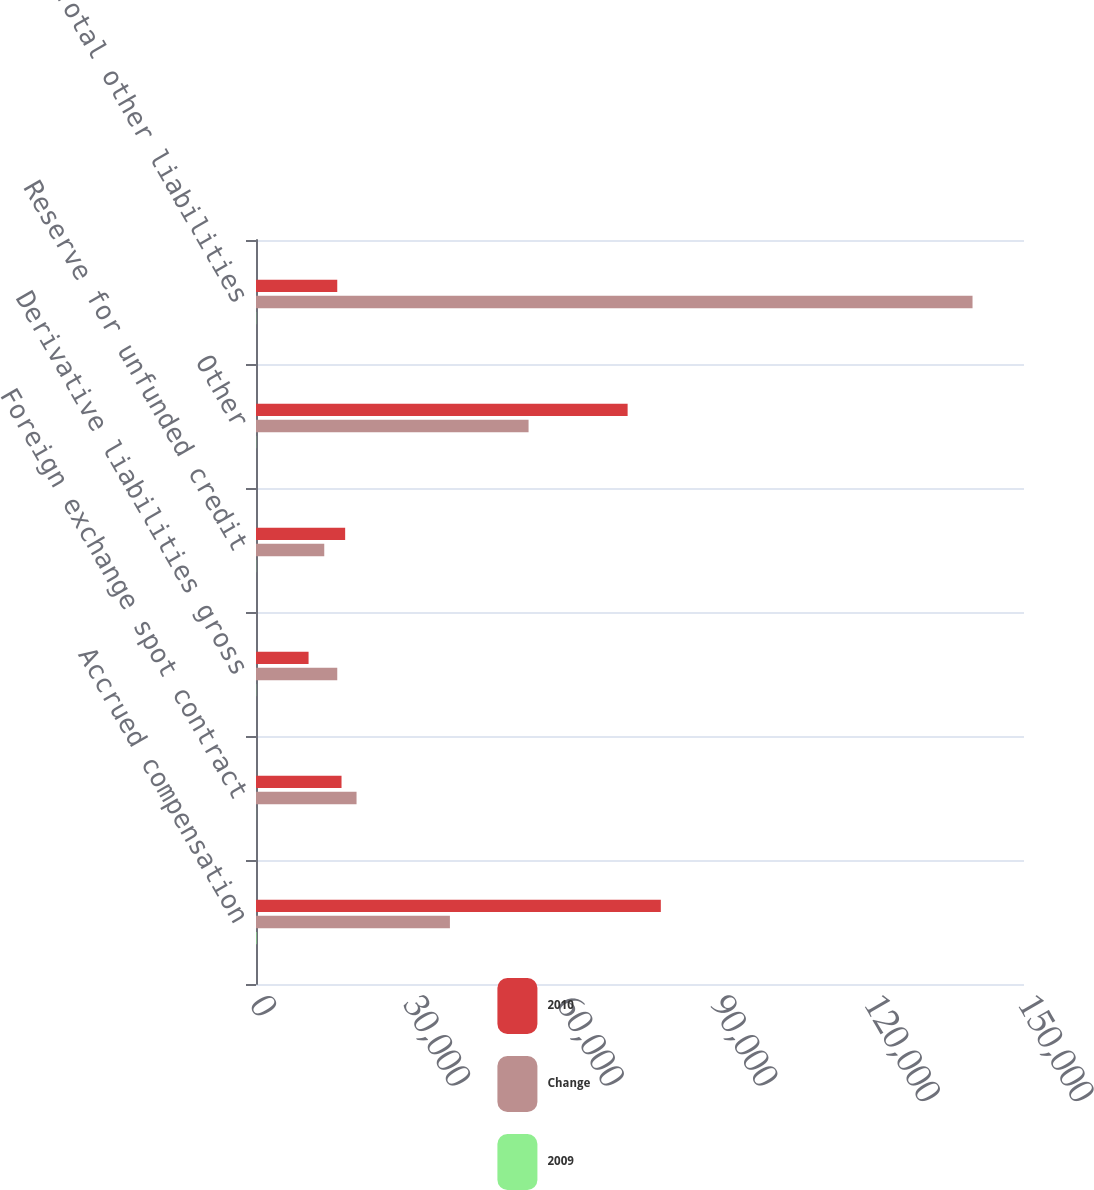<chart> <loc_0><loc_0><loc_500><loc_500><stacked_bar_chart><ecel><fcel>Accrued compensation<fcel>Foreign exchange spot contract<fcel>Derivative liabilities gross<fcel>Reserve for unfunded credit<fcel>Other<fcel>Total other liabilities<nl><fcel>2010<fcel>79068<fcel>16705<fcel>10267<fcel>17414<fcel>72583<fcel>15870<nl><fcel>Change<fcel>37873<fcel>19638<fcel>15870<fcel>13331<fcel>53235<fcel>139947<nl><fcel>2009<fcel>108.8<fcel>14.9<fcel>35.3<fcel>30.6<fcel>36.3<fcel>40.1<nl></chart> 